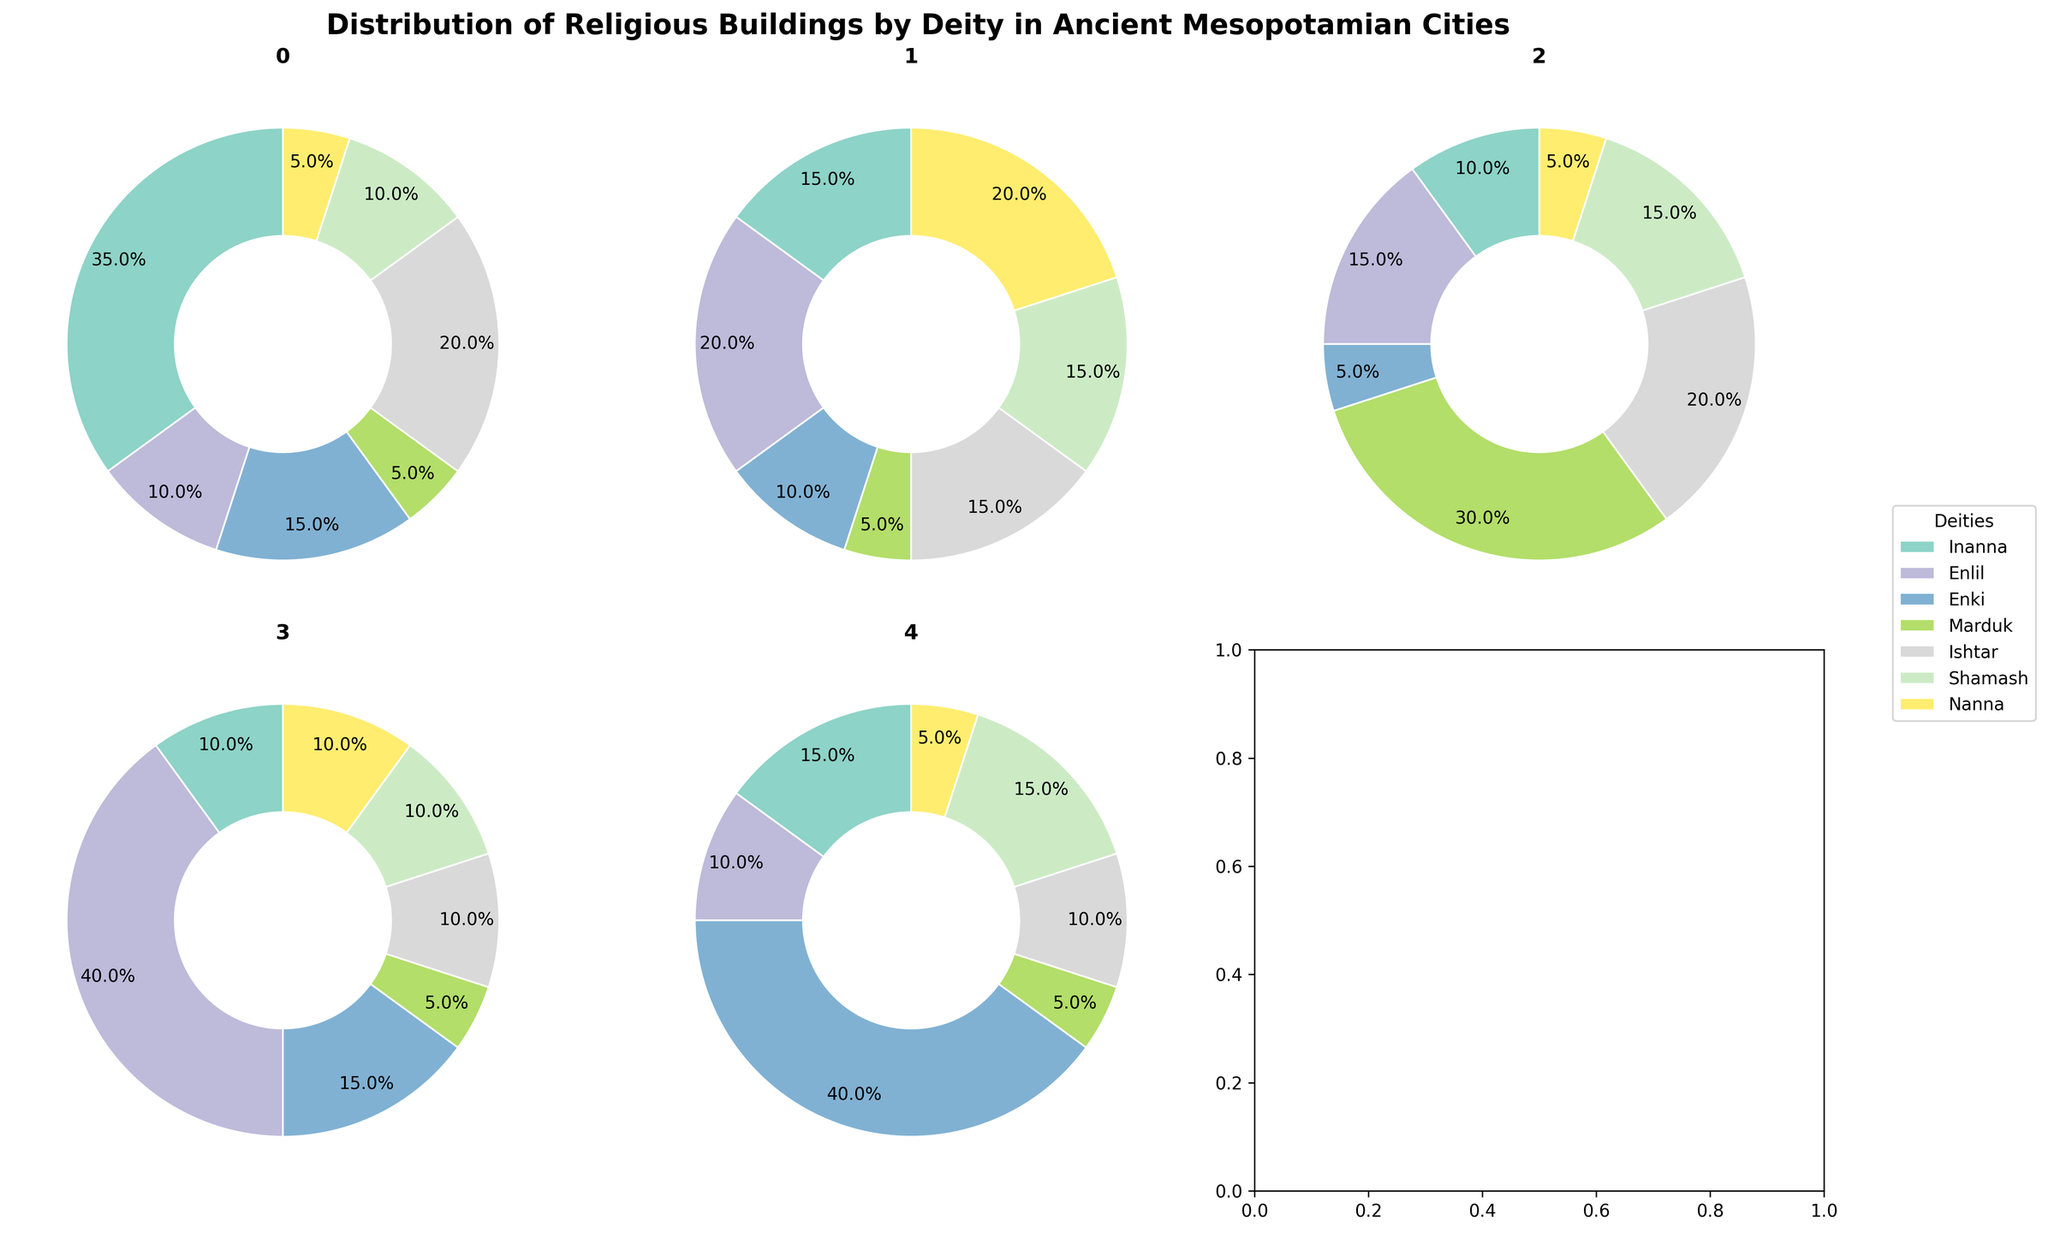What city has the highest proportion of religious buildings dedicated to Enlil? To find the city with the highest proportion of religious buildings dedicated to Enlil, examine the pie charts for the slices labeled Enlil. Nippur has the largest slice for Enlil, at 40%.
Answer: Nippur Which deity has the highest proportion of religious buildings in Eridu? Look at the pie chart for Eridu and identify the largest slice. Enki has the largest proportion at 40%.
Answer: Enki In which city is the proportion of buildings dedicated to Marduk the highest? Check the pie charts for the slice labeled Marduk. Babylon has the highest proportion at 30%.
Answer: Babylon What's the combined proportion of religious buildings for Shamash and Nanna in Ur? Sum the proportions for Shamash and Nanna in Ur. Shamash is 15% and Nanna is 20%, so the combined proportion is 15% + 20% = 35%.
Answer: 35% Compare the proportion of religious buildings dedicated to Inanna between Uruk and Ur. Which city has a higher proportion? Compare the proportion of the slices dedicated to Inanna in both Uruk and Ur. Uruk has 35% while Ur has 15%. Uruk has a higher proportion.
Answer: Uruk Which city has the lowest proportion of religious buildings dedicated to Ishtar? Examine the pie charts for the slices labeled Ishtar and find the smallest proportion. Eridu and Nippur both have 10%, which are the lowest.
Answer: Eridu and Nippur How does the proportion of buildings for Enki in Eridu compare to that in Babylon? Compare the proportions of the slices for Enki between Eridu and Babylon. Eridu has 40% and Babylon has 5%, so Eridu has a higher proportion.
Answer: Eridu What is the median proportion of religious buildings dedicated to all deities in Uruk? List the proportions for Uruk: Inanna 35%, Enlil 10%, Enki 15%, Marduk 5%, Ishtar 20%, Shamash 10%, Nanna 5%. Ordering them gives 5%, 5%, 10%, 10%, 15%, 20%, 35%. The median is the middle value, which is 10%.
Answer: 10% Which deity is equally represented in Ur and Babylon? Look at the proportions in Ur and Babylon and find the deity with the same proportion in both cities. Both Ishtar and Shamash are each 15% in both Ur and Babylon.
Answer: Ishtar and Shamash What is the total proportion of religious buildings dedicated to Inanna across all cities? Sum the proportions of religious buildings for Inanna across all cities: Uruk 35%, Ur 15%, Babylon 10%, Nippur 10%, Eridu 15%. The total is 35% + 15% + 10% + 10% + 15% = 85%.
Answer: 85% 